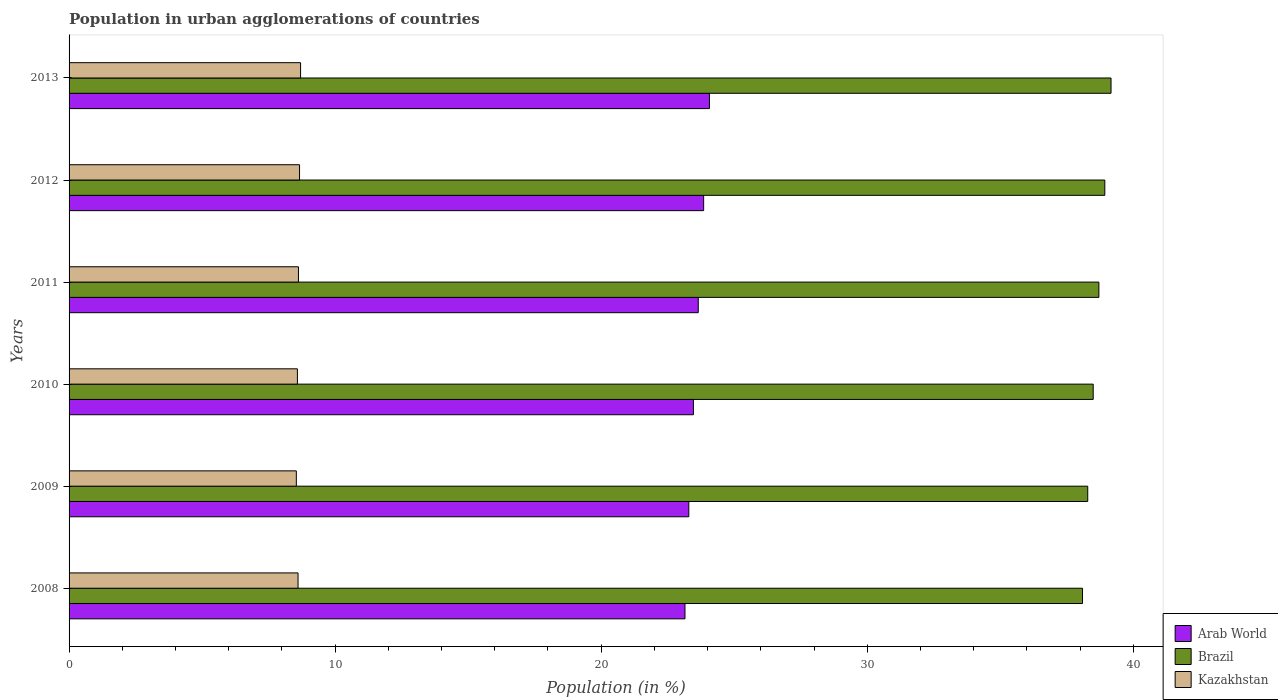How many groups of bars are there?
Your answer should be very brief. 6. How many bars are there on the 2nd tick from the top?
Make the answer very short. 3. How many bars are there on the 1st tick from the bottom?
Provide a short and direct response. 3. In how many cases, is the number of bars for a given year not equal to the number of legend labels?
Ensure brevity in your answer.  0. What is the percentage of population in urban agglomerations in Kazakhstan in 2012?
Ensure brevity in your answer.  8.66. Across all years, what is the maximum percentage of population in urban agglomerations in Arab World?
Provide a succinct answer. 24.07. Across all years, what is the minimum percentage of population in urban agglomerations in Kazakhstan?
Provide a short and direct response. 8.54. What is the total percentage of population in urban agglomerations in Kazakhstan in the graph?
Your answer should be compact. 51.71. What is the difference between the percentage of population in urban agglomerations in Arab World in 2011 and that in 2013?
Give a very brief answer. -0.42. What is the difference between the percentage of population in urban agglomerations in Arab World in 2013 and the percentage of population in urban agglomerations in Kazakhstan in 2012?
Provide a short and direct response. 15.41. What is the average percentage of population in urban agglomerations in Kazakhstan per year?
Provide a succinct answer. 8.62. In the year 2008, what is the difference between the percentage of population in urban agglomerations in Arab World and percentage of population in urban agglomerations in Kazakhstan?
Provide a short and direct response. 14.54. What is the ratio of the percentage of population in urban agglomerations in Brazil in 2010 to that in 2013?
Your answer should be compact. 0.98. Is the difference between the percentage of population in urban agglomerations in Arab World in 2009 and 2011 greater than the difference between the percentage of population in urban agglomerations in Kazakhstan in 2009 and 2011?
Keep it short and to the point. No. What is the difference between the highest and the second highest percentage of population in urban agglomerations in Kazakhstan?
Make the answer very short. 0.04. What is the difference between the highest and the lowest percentage of population in urban agglomerations in Brazil?
Ensure brevity in your answer.  1.07. In how many years, is the percentage of population in urban agglomerations in Arab World greater than the average percentage of population in urban agglomerations in Arab World taken over all years?
Keep it short and to the point. 3. Is the sum of the percentage of population in urban agglomerations in Brazil in 2011 and 2012 greater than the maximum percentage of population in urban agglomerations in Kazakhstan across all years?
Provide a short and direct response. Yes. What does the 3rd bar from the bottom in 2011 represents?
Make the answer very short. Kazakhstan. How many years are there in the graph?
Give a very brief answer. 6. What is the difference between two consecutive major ticks on the X-axis?
Ensure brevity in your answer.  10. Are the values on the major ticks of X-axis written in scientific E-notation?
Provide a succinct answer. No. Does the graph contain any zero values?
Your answer should be very brief. No. How many legend labels are there?
Offer a terse response. 3. What is the title of the graph?
Your answer should be compact. Population in urban agglomerations of countries. What is the label or title of the Y-axis?
Make the answer very short. Years. What is the Population (in %) in Arab World in 2008?
Offer a very short reply. 23.15. What is the Population (in %) of Brazil in 2008?
Give a very brief answer. 38.09. What is the Population (in %) in Kazakhstan in 2008?
Your answer should be very brief. 8.61. What is the Population (in %) of Arab World in 2009?
Your answer should be very brief. 23.29. What is the Population (in %) of Brazil in 2009?
Offer a terse response. 38.29. What is the Population (in %) of Kazakhstan in 2009?
Offer a very short reply. 8.54. What is the Population (in %) of Arab World in 2010?
Your response must be concise. 23.47. What is the Population (in %) of Brazil in 2010?
Provide a succinct answer. 38.49. What is the Population (in %) in Kazakhstan in 2010?
Provide a succinct answer. 8.58. What is the Population (in %) of Arab World in 2011?
Provide a succinct answer. 23.65. What is the Population (in %) of Brazil in 2011?
Your answer should be compact. 38.71. What is the Population (in %) of Kazakhstan in 2011?
Provide a succinct answer. 8.62. What is the Population (in %) of Arab World in 2012?
Ensure brevity in your answer.  23.85. What is the Population (in %) of Brazil in 2012?
Offer a very short reply. 38.93. What is the Population (in %) in Kazakhstan in 2012?
Make the answer very short. 8.66. What is the Population (in %) in Arab World in 2013?
Your answer should be very brief. 24.07. What is the Population (in %) in Brazil in 2013?
Your answer should be very brief. 39.16. What is the Population (in %) in Kazakhstan in 2013?
Make the answer very short. 8.7. Across all years, what is the maximum Population (in %) in Arab World?
Offer a terse response. 24.07. Across all years, what is the maximum Population (in %) in Brazil?
Keep it short and to the point. 39.16. Across all years, what is the maximum Population (in %) of Kazakhstan?
Your answer should be compact. 8.7. Across all years, what is the minimum Population (in %) in Arab World?
Ensure brevity in your answer.  23.15. Across all years, what is the minimum Population (in %) of Brazil?
Offer a terse response. 38.09. Across all years, what is the minimum Population (in %) of Kazakhstan?
Provide a succinct answer. 8.54. What is the total Population (in %) of Arab World in the graph?
Provide a short and direct response. 141.48. What is the total Population (in %) in Brazil in the graph?
Keep it short and to the point. 231.67. What is the total Population (in %) of Kazakhstan in the graph?
Give a very brief answer. 51.71. What is the difference between the Population (in %) of Arab World in 2008 and that in 2009?
Give a very brief answer. -0.14. What is the difference between the Population (in %) in Brazil in 2008 and that in 2009?
Your response must be concise. -0.2. What is the difference between the Population (in %) in Kazakhstan in 2008 and that in 2009?
Your answer should be compact. 0.06. What is the difference between the Population (in %) in Arab World in 2008 and that in 2010?
Offer a terse response. -0.32. What is the difference between the Population (in %) in Brazil in 2008 and that in 2010?
Keep it short and to the point. -0.4. What is the difference between the Population (in %) of Kazakhstan in 2008 and that in 2010?
Offer a terse response. 0.02. What is the difference between the Population (in %) of Arab World in 2008 and that in 2011?
Offer a terse response. -0.5. What is the difference between the Population (in %) of Brazil in 2008 and that in 2011?
Give a very brief answer. -0.61. What is the difference between the Population (in %) in Kazakhstan in 2008 and that in 2011?
Offer a very short reply. -0.02. What is the difference between the Population (in %) of Arab World in 2008 and that in 2012?
Keep it short and to the point. -0.7. What is the difference between the Population (in %) in Brazil in 2008 and that in 2012?
Your answer should be very brief. -0.84. What is the difference between the Population (in %) in Kazakhstan in 2008 and that in 2012?
Provide a succinct answer. -0.06. What is the difference between the Population (in %) of Arab World in 2008 and that in 2013?
Your answer should be compact. -0.92. What is the difference between the Population (in %) in Brazil in 2008 and that in 2013?
Give a very brief answer. -1.07. What is the difference between the Population (in %) in Kazakhstan in 2008 and that in 2013?
Offer a very short reply. -0.1. What is the difference between the Population (in %) of Arab World in 2009 and that in 2010?
Your answer should be compact. -0.17. What is the difference between the Population (in %) of Brazil in 2009 and that in 2010?
Ensure brevity in your answer.  -0.21. What is the difference between the Population (in %) of Kazakhstan in 2009 and that in 2010?
Your response must be concise. -0.04. What is the difference between the Population (in %) in Arab World in 2009 and that in 2011?
Provide a short and direct response. -0.36. What is the difference between the Population (in %) in Brazil in 2009 and that in 2011?
Your answer should be very brief. -0.42. What is the difference between the Population (in %) of Kazakhstan in 2009 and that in 2011?
Ensure brevity in your answer.  -0.08. What is the difference between the Population (in %) in Arab World in 2009 and that in 2012?
Offer a very short reply. -0.56. What is the difference between the Population (in %) of Brazil in 2009 and that in 2012?
Provide a succinct answer. -0.64. What is the difference between the Population (in %) of Kazakhstan in 2009 and that in 2012?
Provide a succinct answer. -0.12. What is the difference between the Population (in %) of Arab World in 2009 and that in 2013?
Provide a succinct answer. -0.78. What is the difference between the Population (in %) of Brazil in 2009 and that in 2013?
Offer a terse response. -0.88. What is the difference between the Population (in %) of Kazakhstan in 2009 and that in 2013?
Give a very brief answer. -0.16. What is the difference between the Population (in %) in Arab World in 2010 and that in 2011?
Offer a terse response. -0.18. What is the difference between the Population (in %) in Brazil in 2010 and that in 2011?
Your answer should be very brief. -0.21. What is the difference between the Population (in %) of Kazakhstan in 2010 and that in 2011?
Offer a terse response. -0.04. What is the difference between the Population (in %) of Arab World in 2010 and that in 2012?
Your response must be concise. -0.38. What is the difference between the Population (in %) in Brazil in 2010 and that in 2012?
Make the answer very short. -0.44. What is the difference between the Population (in %) of Kazakhstan in 2010 and that in 2012?
Offer a terse response. -0.08. What is the difference between the Population (in %) of Arab World in 2010 and that in 2013?
Offer a terse response. -0.6. What is the difference between the Population (in %) of Brazil in 2010 and that in 2013?
Your answer should be very brief. -0.67. What is the difference between the Population (in %) in Kazakhstan in 2010 and that in 2013?
Provide a succinct answer. -0.12. What is the difference between the Population (in %) of Arab World in 2011 and that in 2012?
Offer a very short reply. -0.2. What is the difference between the Population (in %) in Brazil in 2011 and that in 2012?
Your answer should be very brief. -0.22. What is the difference between the Population (in %) in Kazakhstan in 2011 and that in 2012?
Give a very brief answer. -0.04. What is the difference between the Population (in %) in Arab World in 2011 and that in 2013?
Keep it short and to the point. -0.42. What is the difference between the Population (in %) of Brazil in 2011 and that in 2013?
Offer a very short reply. -0.46. What is the difference between the Population (in %) in Kazakhstan in 2011 and that in 2013?
Your response must be concise. -0.08. What is the difference between the Population (in %) in Arab World in 2012 and that in 2013?
Give a very brief answer. -0.22. What is the difference between the Population (in %) of Brazil in 2012 and that in 2013?
Provide a succinct answer. -0.23. What is the difference between the Population (in %) of Kazakhstan in 2012 and that in 2013?
Offer a terse response. -0.04. What is the difference between the Population (in %) in Arab World in 2008 and the Population (in %) in Brazil in 2009?
Provide a succinct answer. -15.14. What is the difference between the Population (in %) of Arab World in 2008 and the Population (in %) of Kazakhstan in 2009?
Your response must be concise. 14.61. What is the difference between the Population (in %) in Brazil in 2008 and the Population (in %) in Kazakhstan in 2009?
Give a very brief answer. 29.55. What is the difference between the Population (in %) in Arab World in 2008 and the Population (in %) in Brazil in 2010?
Your answer should be very brief. -15.34. What is the difference between the Population (in %) in Arab World in 2008 and the Population (in %) in Kazakhstan in 2010?
Your answer should be compact. 14.57. What is the difference between the Population (in %) in Brazil in 2008 and the Population (in %) in Kazakhstan in 2010?
Offer a terse response. 29.51. What is the difference between the Population (in %) of Arab World in 2008 and the Population (in %) of Brazil in 2011?
Your response must be concise. -15.56. What is the difference between the Population (in %) in Arab World in 2008 and the Population (in %) in Kazakhstan in 2011?
Provide a short and direct response. 14.53. What is the difference between the Population (in %) in Brazil in 2008 and the Population (in %) in Kazakhstan in 2011?
Ensure brevity in your answer.  29.47. What is the difference between the Population (in %) of Arab World in 2008 and the Population (in %) of Brazil in 2012?
Your answer should be very brief. -15.78. What is the difference between the Population (in %) in Arab World in 2008 and the Population (in %) in Kazakhstan in 2012?
Offer a terse response. 14.49. What is the difference between the Population (in %) in Brazil in 2008 and the Population (in %) in Kazakhstan in 2012?
Provide a succinct answer. 29.43. What is the difference between the Population (in %) in Arab World in 2008 and the Population (in %) in Brazil in 2013?
Provide a succinct answer. -16.01. What is the difference between the Population (in %) in Arab World in 2008 and the Population (in %) in Kazakhstan in 2013?
Ensure brevity in your answer.  14.45. What is the difference between the Population (in %) of Brazil in 2008 and the Population (in %) of Kazakhstan in 2013?
Provide a succinct answer. 29.39. What is the difference between the Population (in %) of Arab World in 2009 and the Population (in %) of Brazil in 2010?
Your answer should be compact. -15.2. What is the difference between the Population (in %) in Arab World in 2009 and the Population (in %) in Kazakhstan in 2010?
Offer a terse response. 14.71. What is the difference between the Population (in %) in Brazil in 2009 and the Population (in %) in Kazakhstan in 2010?
Ensure brevity in your answer.  29.7. What is the difference between the Population (in %) in Arab World in 2009 and the Population (in %) in Brazil in 2011?
Offer a terse response. -15.41. What is the difference between the Population (in %) of Arab World in 2009 and the Population (in %) of Kazakhstan in 2011?
Your answer should be very brief. 14.67. What is the difference between the Population (in %) in Brazil in 2009 and the Population (in %) in Kazakhstan in 2011?
Ensure brevity in your answer.  29.66. What is the difference between the Population (in %) in Arab World in 2009 and the Population (in %) in Brazil in 2012?
Provide a short and direct response. -15.64. What is the difference between the Population (in %) in Arab World in 2009 and the Population (in %) in Kazakhstan in 2012?
Your answer should be very brief. 14.63. What is the difference between the Population (in %) of Brazil in 2009 and the Population (in %) of Kazakhstan in 2012?
Give a very brief answer. 29.62. What is the difference between the Population (in %) in Arab World in 2009 and the Population (in %) in Brazil in 2013?
Offer a terse response. -15.87. What is the difference between the Population (in %) in Arab World in 2009 and the Population (in %) in Kazakhstan in 2013?
Provide a succinct answer. 14.59. What is the difference between the Population (in %) of Brazil in 2009 and the Population (in %) of Kazakhstan in 2013?
Provide a short and direct response. 29.59. What is the difference between the Population (in %) in Arab World in 2010 and the Population (in %) in Brazil in 2011?
Provide a short and direct response. -15.24. What is the difference between the Population (in %) of Arab World in 2010 and the Population (in %) of Kazakhstan in 2011?
Keep it short and to the point. 14.84. What is the difference between the Population (in %) of Brazil in 2010 and the Population (in %) of Kazakhstan in 2011?
Offer a terse response. 29.87. What is the difference between the Population (in %) in Arab World in 2010 and the Population (in %) in Brazil in 2012?
Make the answer very short. -15.46. What is the difference between the Population (in %) of Arab World in 2010 and the Population (in %) of Kazakhstan in 2012?
Ensure brevity in your answer.  14.8. What is the difference between the Population (in %) in Brazil in 2010 and the Population (in %) in Kazakhstan in 2012?
Offer a terse response. 29.83. What is the difference between the Population (in %) in Arab World in 2010 and the Population (in %) in Brazil in 2013?
Your answer should be compact. -15.7. What is the difference between the Population (in %) of Arab World in 2010 and the Population (in %) of Kazakhstan in 2013?
Make the answer very short. 14.77. What is the difference between the Population (in %) in Brazil in 2010 and the Population (in %) in Kazakhstan in 2013?
Keep it short and to the point. 29.79. What is the difference between the Population (in %) of Arab World in 2011 and the Population (in %) of Brazil in 2012?
Provide a short and direct response. -15.28. What is the difference between the Population (in %) in Arab World in 2011 and the Population (in %) in Kazakhstan in 2012?
Make the answer very short. 14.99. What is the difference between the Population (in %) of Brazil in 2011 and the Population (in %) of Kazakhstan in 2012?
Provide a short and direct response. 30.04. What is the difference between the Population (in %) of Arab World in 2011 and the Population (in %) of Brazil in 2013?
Ensure brevity in your answer.  -15.51. What is the difference between the Population (in %) of Arab World in 2011 and the Population (in %) of Kazakhstan in 2013?
Offer a very short reply. 14.95. What is the difference between the Population (in %) in Brazil in 2011 and the Population (in %) in Kazakhstan in 2013?
Provide a short and direct response. 30. What is the difference between the Population (in %) in Arab World in 2012 and the Population (in %) in Brazil in 2013?
Provide a short and direct response. -15.31. What is the difference between the Population (in %) in Arab World in 2012 and the Population (in %) in Kazakhstan in 2013?
Provide a succinct answer. 15.15. What is the difference between the Population (in %) in Brazil in 2012 and the Population (in %) in Kazakhstan in 2013?
Your response must be concise. 30.23. What is the average Population (in %) in Arab World per year?
Your answer should be compact. 23.58. What is the average Population (in %) in Brazil per year?
Offer a terse response. 38.61. What is the average Population (in %) of Kazakhstan per year?
Keep it short and to the point. 8.62. In the year 2008, what is the difference between the Population (in %) in Arab World and Population (in %) in Brazil?
Make the answer very short. -14.94. In the year 2008, what is the difference between the Population (in %) in Arab World and Population (in %) in Kazakhstan?
Provide a short and direct response. 14.54. In the year 2008, what is the difference between the Population (in %) of Brazil and Population (in %) of Kazakhstan?
Make the answer very short. 29.48. In the year 2009, what is the difference between the Population (in %) in Arab World and Population (in %) in Brazil?
Your answer should be very brief. -14.99. In the year 2009, what is the difference between the Population (in %) of Arab World and Population (in %) of Kazakhstan?
Offer a very short reply. 14.75. In the year 2009, what is the difference between the Population (in %) in Brazil and Population (in %) in Kazakhstan?
Keep it short and to the point. 29.74. In the year 2010, what is the difference between the Population (in %) of Arab World and Population (in %) of Brazil?
Offer a very short reply. -15.03. In the year 2010, what is the difference between the Population (in %) of Arab World and Population (in %) of Kazakhstan?
Provide a succinct answer. 14.88. In the year 2010, what is the difference between the Population (in %) in Brazil and Population (in %) in Kazakhstan?
Ensure brevity in your answer.  29.91. In the year 2011, what is the difference between the Population (in %) in Arab World and Population (in %) in Brazil?
Provide a succinct answer. -15.06. In the year 2011, what is the difference between the Population (in %) in Arab World and Population (in %) in Kazakhstan?
Provide a short and direct response. 15.03. In the year 2011, what is the difference between the Population (in %) in Brazil and Population (in %) in Kazakhstan?
Offer a very short reply. 30.08. In the year 2012, what is the difference between the Population (in %) of Arab World and Population (in %) of Brazil?
Your answer should be very brief. -15.08. In the year 2012, what is the difference between the Population (in %) in Arab World and Population (in %) in Kazakhstan?
Your response must be concise. 15.19. In the year 2012, what is the difference between the Population (in %) of Brazil and Population (in %) of Kazakhstan?
Make the answer very short. 30.27. In the year 2013, what is the difference between the Population (in %) in Arab World and Population (in %) in Brazil?
Provide a short and direct response. -15.09. In the year 2013, what is the difference between the Population (in %) of Arab World and Population (in %) of Kazakhstan?
Offer a terse response. 15.37. In the year 2013, what is the difference between the Population (in %) in Brazil and Population (in %) in Kazakhstan?
Provide a short and direct response. 30.46. What is the ratio of the Population (in %) of Kazakhstan in 2008 to that in 2009?
Your answer should be compact. 1.01. What is the ratio of the Population (in %) of Arab World in 2008 to that in 2010?
Make the answer very short. 0.99. What is the ratio of the Population (in %) in Brazil in 2008 to that in 2010?
Your response must be concise. 0.99. What is the ratio of the Population (in %) of Arab World in 2008 to that in 2011?
Your response must be concise. 0.98. What is the ratio of the Population (in %) in Brazil in 2008 to that in 2011?
Your answer should be very brief. 0.98. What is the ratio of the Population (in %) in Kazakhstan in 2008 to that in 2011?
Make the answer very short. 1. What is the ratio of the Population (in %) in Arab World in 2008 to that in 2012?
Offer a very short reply. 0.97. What is the ratio of the Population (in %) in Brazil in 2008 to that in 2012?
Your answer should be very brief. 0.98. What is the ratio of the Population (in %) in Kazakhstan in 2008 to that in 2012?
Ensure brevity in your answer.  0.99. What is the ratio of the Population (in %) in Arab World in 2008 to that in 2013?
Your answer should be very brief. 0.96. What is the ratio of the Population (in %) of Brazil in 2008 to that in 2013?
Your answer should be very brief. 0.97. What is the ratio of the Population (in %) of Brazil in 2009 to that in 2010?
Your answer should be compact. 0.99. What is the ratio of the Population (in %) in Arab World in 2009 to that in 2011?
Your answer should be compact. 0.98. What is the ratio of the Population (in %) of Brazil in 2009 to that in 2011?
Keep it short and to the point. 0.99. What is the ratio of the Population (in %) in Kazakhstan in 2009 to that in 2011?
Provide a short and direct response. 0.99. What is the ratio of the Population (in %) in Arab World in 2009 to that in 2012?
Ensure brevity in your answer.  0.98. What is the ratio of the Population (in %) in Brazil in 2009 to that in 2012?
Offer a very short reply. 0.98. What is the ratio of the Population (in %) of Kazakhstan in 2009 to that in 2012?
Provide a short and direct response. 0.99. What is the ratio of the Population (in %) of Arab World in 2009 to that in 2013?
Your answer should be very brief. 0.97. What is the ratio of the Population (in %) of Brazil in 2009 to that in 2013?
Your answer should be compact. 0.98. What is the ratio of the Population (in %) in Kazakhstan in 2009 to that in 2013?
Offer a very short reply. 0.98. What is the ratio of the Population (in %) in Arab World in 2010 to that in 2011?
Keep it short and to the point. 0.99. What is the ratio of the Population (in %) in Brazil in 2010 to that in 2011?
Give a very brief answer. 0.99. What is the ratio of the Population (in %) in Arab World in 2010 to that in 2012?
Your answer should be compact. 0.98. What is the ratio of the Population (in %) in Brazil in 2010 to that in 2012?
Make the answer very short. 0.99. What is the ratio of the Population (in %) of Brazil in 2010 to that in 2013?
Provide a short and direct response. 0.98. What is the ratio of the Population (in %) of Kazakhstan in 2010 to that in 2013?
Your answer should be very brief. 0.99. What is the ratio of the Population (in %) of Brazil in 2011 to that in 2012?
Ensure brevity in your answer.  0.99. What is the ratio of the Population (in %) in Arab World in 2011 to that in 2013?
Give a very brief answer. 0.98. What is the ratio of the Population (in %) of Brazil in 2011 to that in 2013?
Provide a succinct answer. 0.99. What is the ratio of the Population (in %) in Kazakhstan in 2011 to that in 2013?
Provide a succinct answer. 0.99. What is the ratio of the Population (in %) of Arab World in 2012 to that in 2013?
Provide a short and direct response. 0.99. What is the ratio of the Population (in %) in Brazil in 2012 to that in 2013?
Offer a very short reply. 0.99. What is the difference between the highest and the second highest Population (in %) of Arab World?
Ensure brevity in your answer.  0.22. What is the difference between the highest and the second highest Population (in %) of Brazil?
Offer a terse response. 0.23. What is the difference between the highest and the second highest Population (in %) of Kazakhstan?
Provide a short and direct response. 0.04. What is the difference between the highest and the lowest Population (in %) in Brazil?
Your answer should be compact. 1.07. What is the difference between the highest and the lowest Population (in %) in Kazakhstan?
Provide a succinct answer. 0.16. 